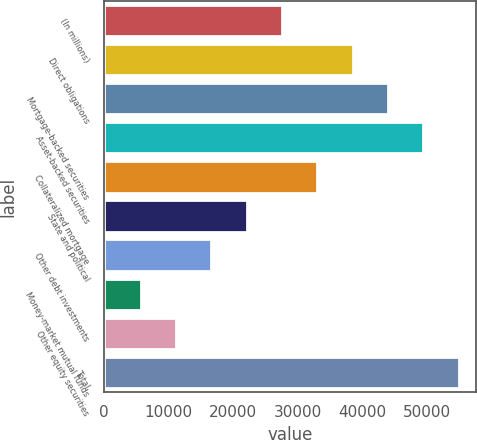Convert chart. <chart><loc_0><loc_0><loc_500><loc_500><bar_chart><fcel>(In millions)<fcel>Direct obligations<fcel>Mortgage-backed securities<fcel>Asset-backed securities<fcel>Collateralized mortgage<fcel>State and political<fcel>Other debt investments<fcel>Money-market mutual funds<fcel>Other equity securities<fcel>Total<nl><fcel>27601<fcel>38552.2<fcel>44027.8<fcel>49503.4<fcel>33076.6<fcel>22125.4<fcel>16649.8<fcel>5698.6<fcel>11174.2<fcel>54979<nl></chart> 